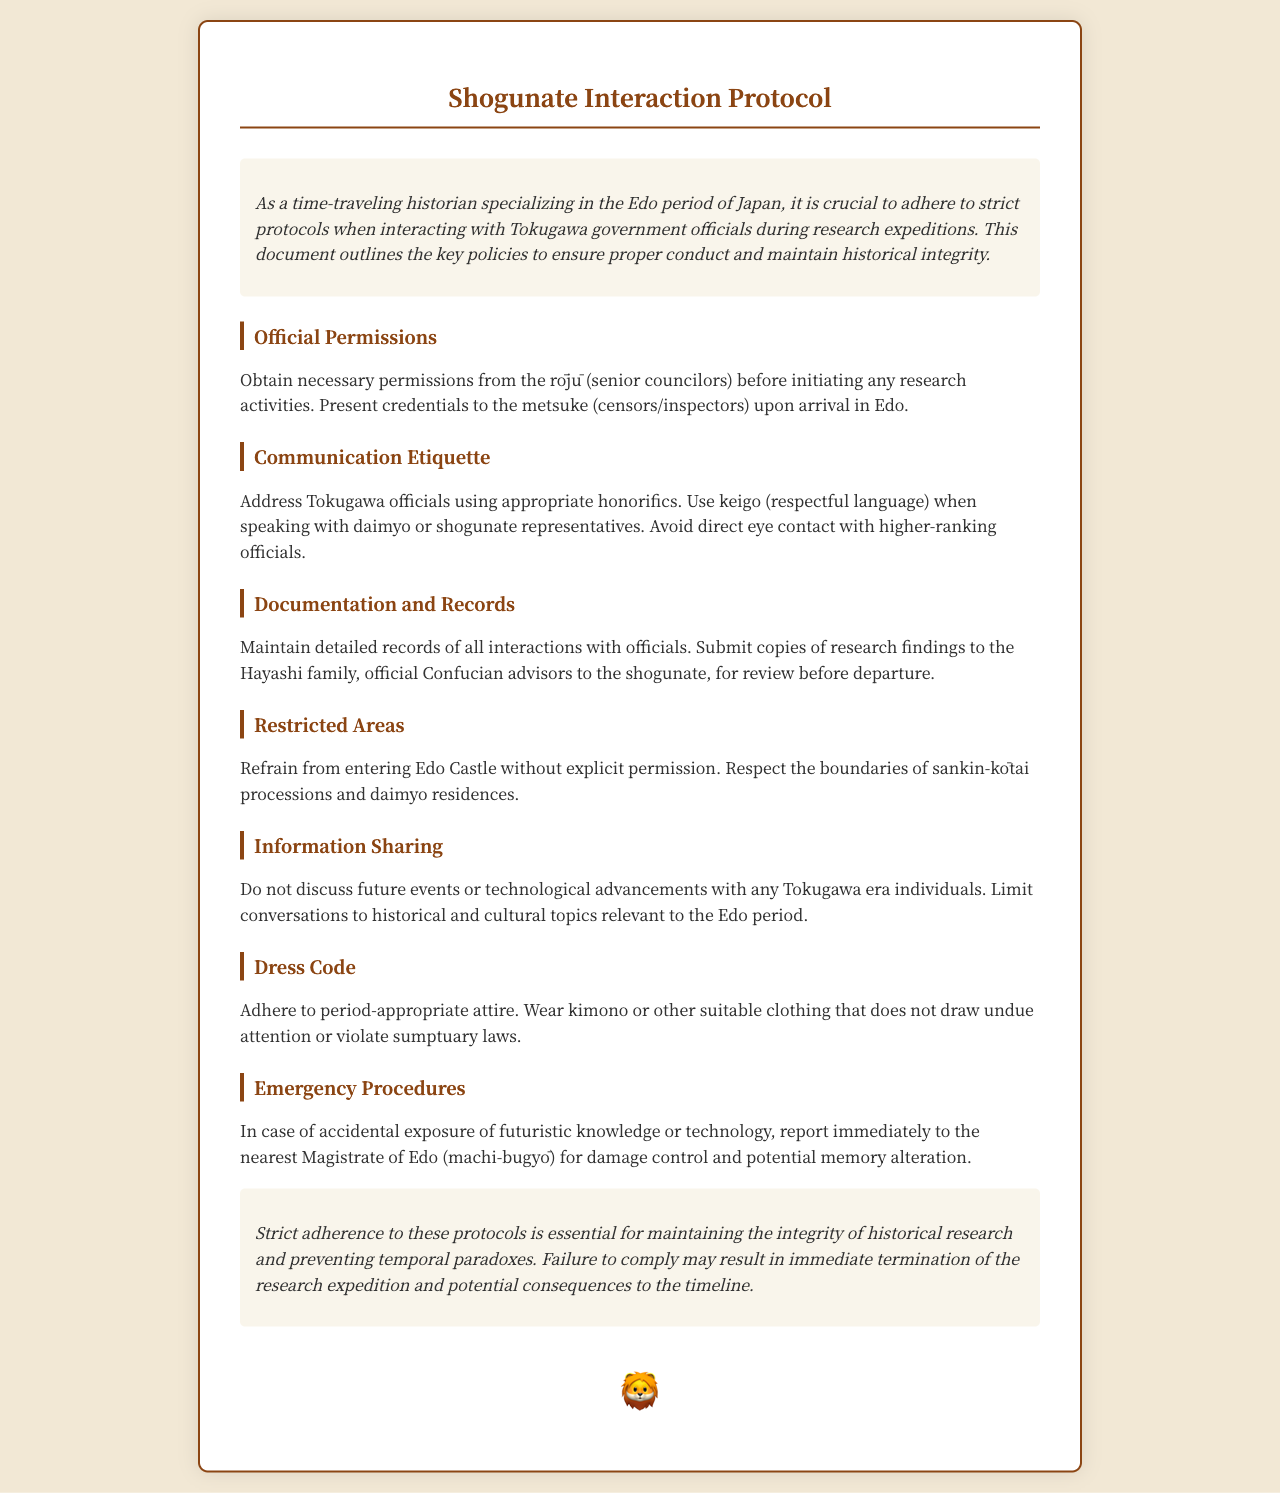What is the title of the document? The title of the document is stated at the top as "Shogunate Interaction Protocol."
Answer: Shogunate Interaction Protocol Who must be approached for official permissions? The document specifies that the rōjū (senior councilors) must be approached for official permissions.
Answer: rōjū What language style should be used when addressing officials? The document instructs the use of keigo (respectful language) when speaking with officials.
Answer: keigo What should be maintained regarding interactions with officials? The document highlights the importance of maintaining detailed records of all interactions.
Answer: detailed records What is the dress code specified in the document? The dress code mentioned requires adherence to period-appropriate attire.
Answer: period-appropriate attire What action should be taken if futuristic knowledge is accidentally exposed? The document advises to report to the nearest Magistrate of Edo for damage control.
Answer: report to the nearest Magistrate of Edo Which family should research findings be submitted to? The research findings must be submitted to the Hayashi family for review.
Answer: Hayashi family What is one area that is strictly off-limits? The document states that entering Edo Castle without permission is a restricted area.
Answer: Edo Castle What may result from failure to comply with the protocols? According to the document, failure to comply may result in immediate termination of the research expedition.
Answer: immediate termination of the research expedition 